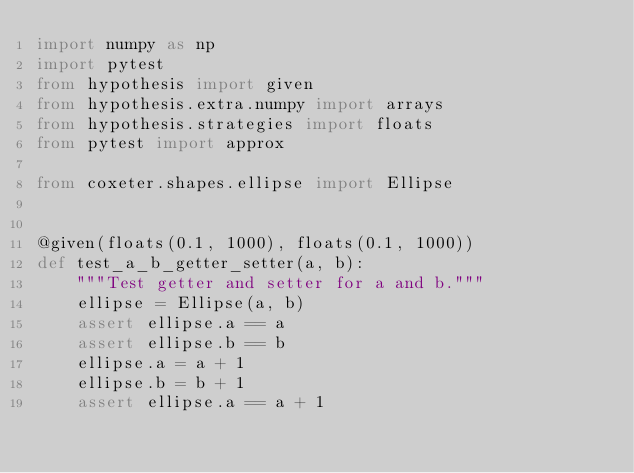Convert code to text. <code><loc_0><loc_0><loc_500><loc_500><_Python_>import numpy as np
import pytest
from hypothesis import given
from hypothesis.extra.numpy import arrays
from hypothesis.strategies import floats
from pytest import approx

from coxeter.shapes.ellipse import Ellipse


@given(floats(0.1, 1000), floats(0.1, 1000))
def test_a_b_getter_setter(a, b):
    """Test getter and setter for a and b."""
    ellipse = Ellipse(a, b)
    assert ellipse.a == a
    assert ellipse.b == b
    ellipse.a = a + 1
    ellipse.b = b + 1
    assert ellipse.a == a + 1</code> 